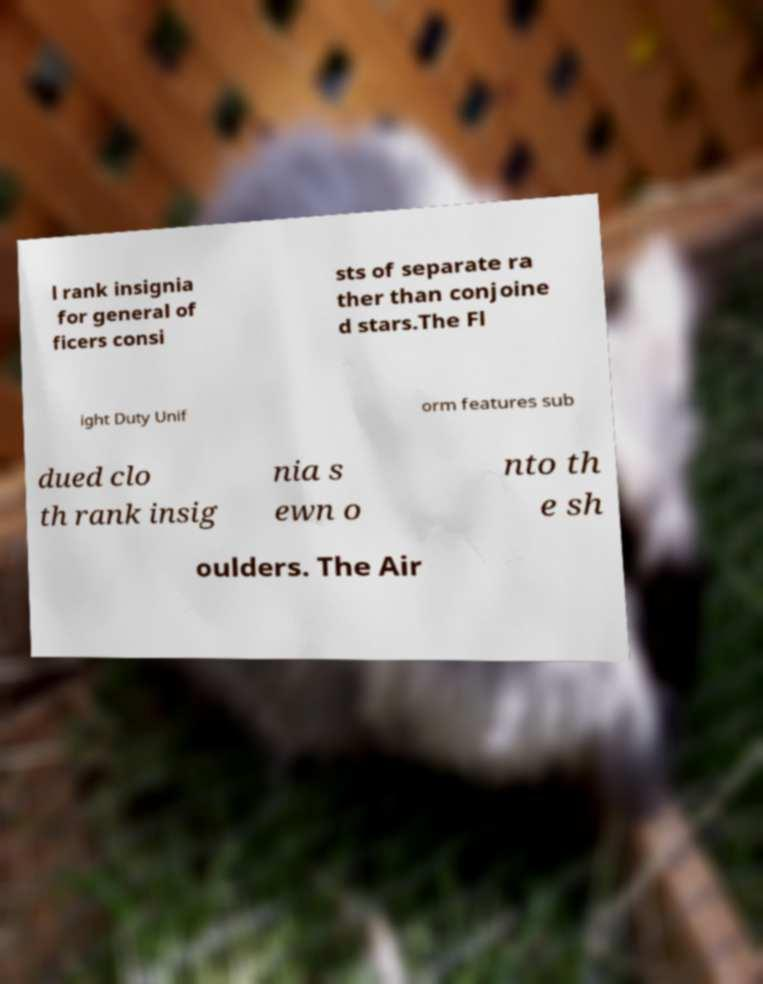Could you extract and type out the text from this image? l rank insignia for general of ficers consi sts of separate ra ther than conjoine d stars.The Fl ight Duty Unif orm features sub dued clo th rank insig nia s ewn o nto th e sh oulders. The Air 